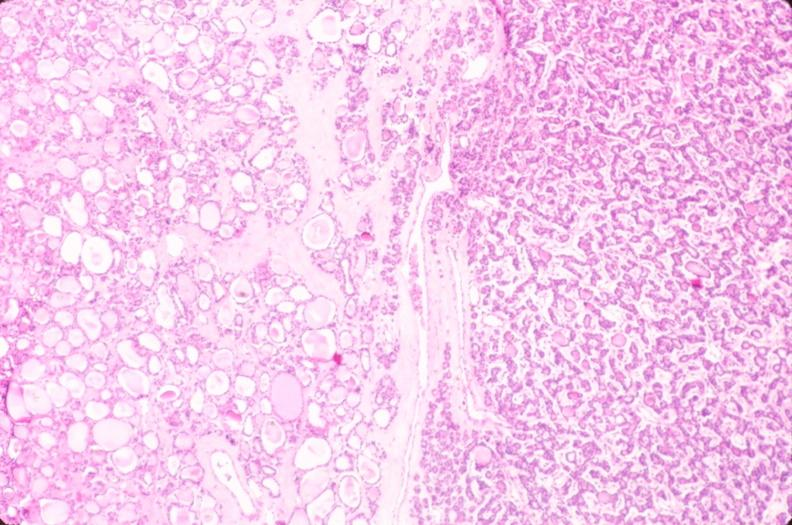where is this part in the figure?
Answer the question using a single word or phrase. Endocrine system 